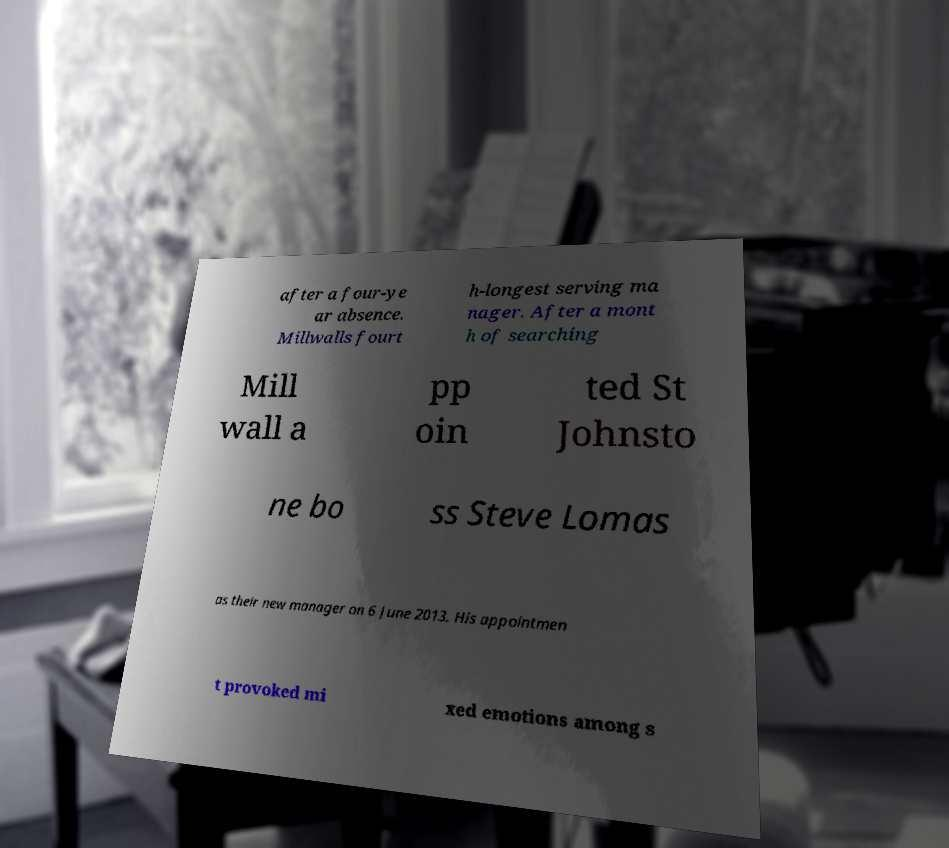Could you assist in decoding the text presented in this image and type it out clearly? after a four-ye ar absence. Millwalls fourt h-longest serving ma nager. After a mont h of searching Mill wall a pp oin ted St Johnsto ne bo ss Steve Lomas as their new manager on 6 June 2013. His appointmen t provoked mi xed emotions among s 